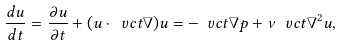<formula> <loc_0><loc_0><loc_500><loc_500>\frac { d u } { d t } = \frac { \partial u } { \partial t } + ( u \cdot \ v c t { \nabla } ) u = - \ v c t { \nabla } p + \nu \ v c t { \nabla } ^ { 2 } u ,</formula> 